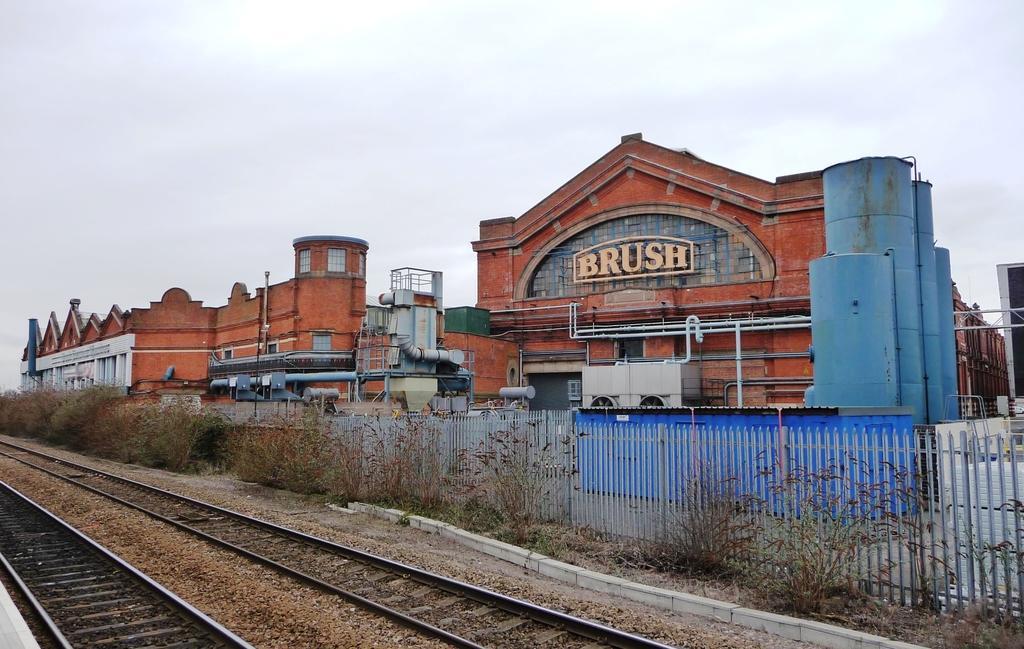Could you give a brief overview of what you see in this image? In this picture we can see the track, side we can see buildings, houses, fencing and some plants. 